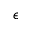Convert formula to latex. <formula><loc_0><loc_0><loc_500><loc_500>\epsilon</formula> 